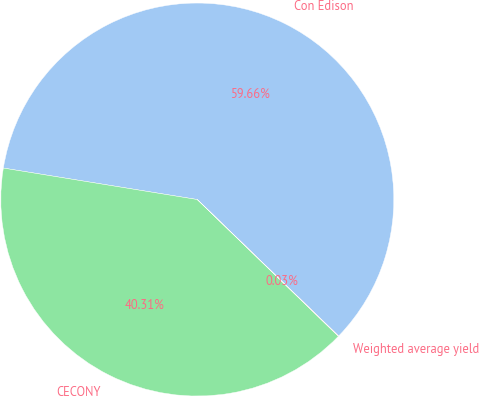Convert chart. <chart><loc_0><loc_0><loc_500><loc_500><pie_chart><fcel>Con Edison<fcel>CECONY<fcel>Weighted average yield<nl><fcel>59.66%<fcel>40.31%<fcel>0.03%<nl></chart> 